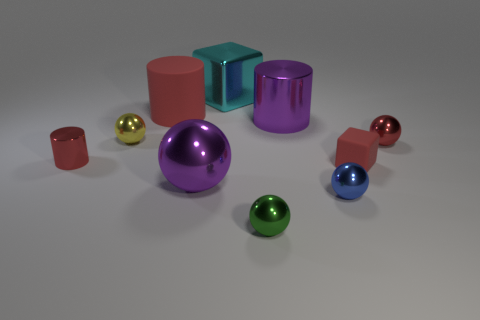Subtract all purple spheres. How many spheres are left? 4 Subtract all green cubes. Subtract all blue balls. How many cubes are left? 2 Subtract all cylinders. How many objects are left? 7 Subtract all tiny things. Subtract all rubber cylinders. How many objects are left? 3 Add 3 small red rubber objects. How many small red rubber objects are left? 4 Add 7 cyan shiny things. How many cyan shiny things exist? 8 Subtract 0 green blocks. How many objects are left? 10 